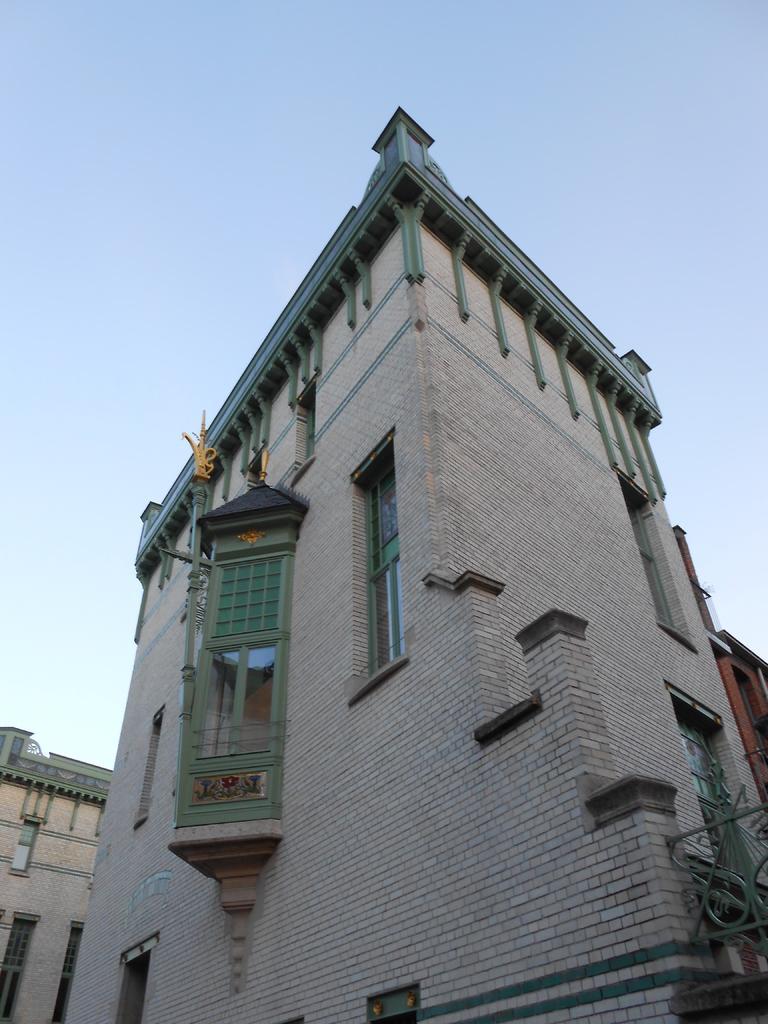Can you describe this image briefly? In the image there is a tall building it has many windows and it is made up of bricks, around that building there are two other buildings on the either side. 